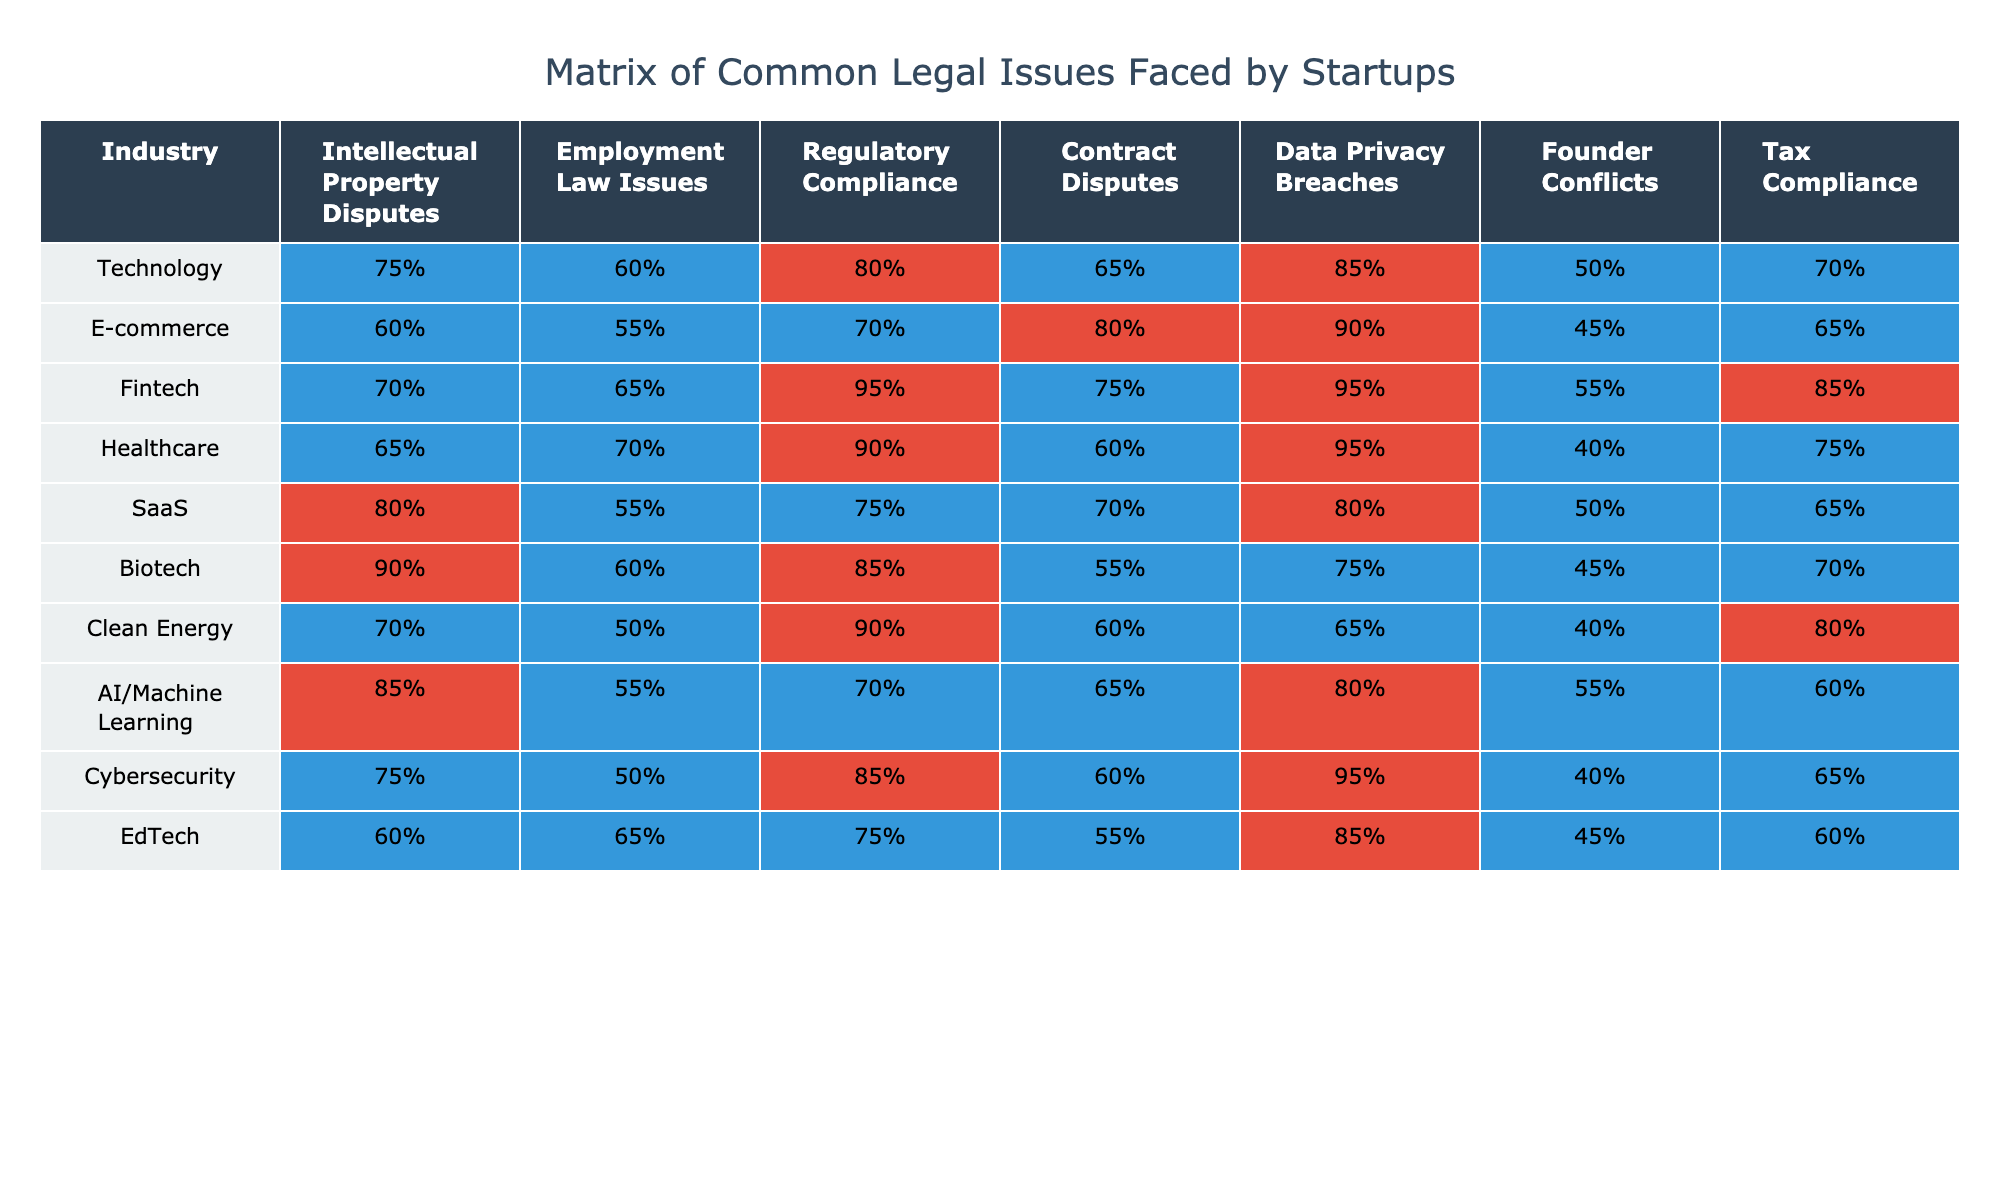What industry has the highest percentage of Intellectual Property Disputes? Looking at the table, Biotech has the highest percentage for Intellectual Property Disputes with 90%.
Answer: Biotech Which industry faces the most frequent Data Privacy Breaches? In the table, Fintech, Healthcare, and Cybersecurity all have 95%, making them the industries facing the most frequent Data Privacy Breaches.
Answer: Fintech, Healthcare, Cybersecurity What percentage of startups in the Technology sector face employment law issues? The Technology sector shows 60% for Employment Law Issues, as can be seen in the table.
Answer: 60% What is the average percentage of Contract Disputes across all industries listed? To find the average, sum the percentages for Contract Disputes across the industries (65 + 80 + 75 + 60 + 70 + 55 + 60 + 65 + 55)/9 = 66.11%.
Answer: 66.11% Are E-commerce startups more likely to experience Founder Conflicts than Clean Energy startups? E-commerce has 45% for Founder Conflicts, while Clean Energy has 40%. Therefore, yes, E-commerce startups are more likely to experience Founder Conflicts than Clean Energy startups.
Answer: Yes What is the difference in frequency of Regulatory Compliance issues between Fintech and AI/Machine Learning industries? Fintech has a frequency of 95% for Regulatory Compliance, while AI/Machine Learning has 70%. The difference is 95% - 70% = 25%.
Answer: 25% Which industry has the lowest frequency of Employment Law Issues, and what is the percentage? The table shows that Clean Energy has the lowest percentage of Employment Law Issues at 50%.
Answer: Clean Energy, 50% If a startup in the Healthcare sector is experiencing both Founder Conflicts and Tax Compliance issues, what can be said about the severity of these issues compared to the average across all sectors? Healthcare's 40% Founder Conflicts and 75% Tax Compliance must be compared to the average of both metrics across all sectors, which may vary. After calculating: The average for Founder Conflicts is 49% and for Tax Compliance is 71%, indicating that Healthcare’s Founder Conflicts are below the average while Tax Compliance is above average.
Answer: Founder Conflicts below average, Tax Compliance above average What is the highest frequency of Tax Compliance issues recorded in any industry? The table indicates that Fintech has the highest frequency of Tax Compliance issues at 85%.
Answer: 85% Is it true that the Technology industry has a higher percentage of Data Privacy Breaches than the SaaS industry? The Technology industry has 85% for Data Privacy Breaches, while the SaaS industry has 80%, meaning it is indeed true that Technology has a higher percentage.
Answer: Yes 